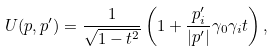Convert formula to latex. <formula><loc_0><loc_0><loc_500><loc_500>U ( p , p ^ { \prime } ) = \frac { 1 } { \sqrt { 1 - t ^ { 2 } } } \left ( 1 + \frac { p ^ { \prime } _ { i } } { | { p } ^ { \prime } | } \gamma _ { 0 } \gamma _ { i } t \right ) ,</formula> 